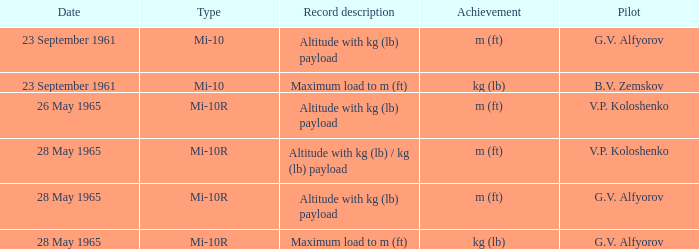What record description corresponds to the achievement of m (ft), a type of mi-10r, a pilot of v.p. koloshenko, and a date of 28 may 1965? Altitude with kg (lb) / kg (lb) payload. 